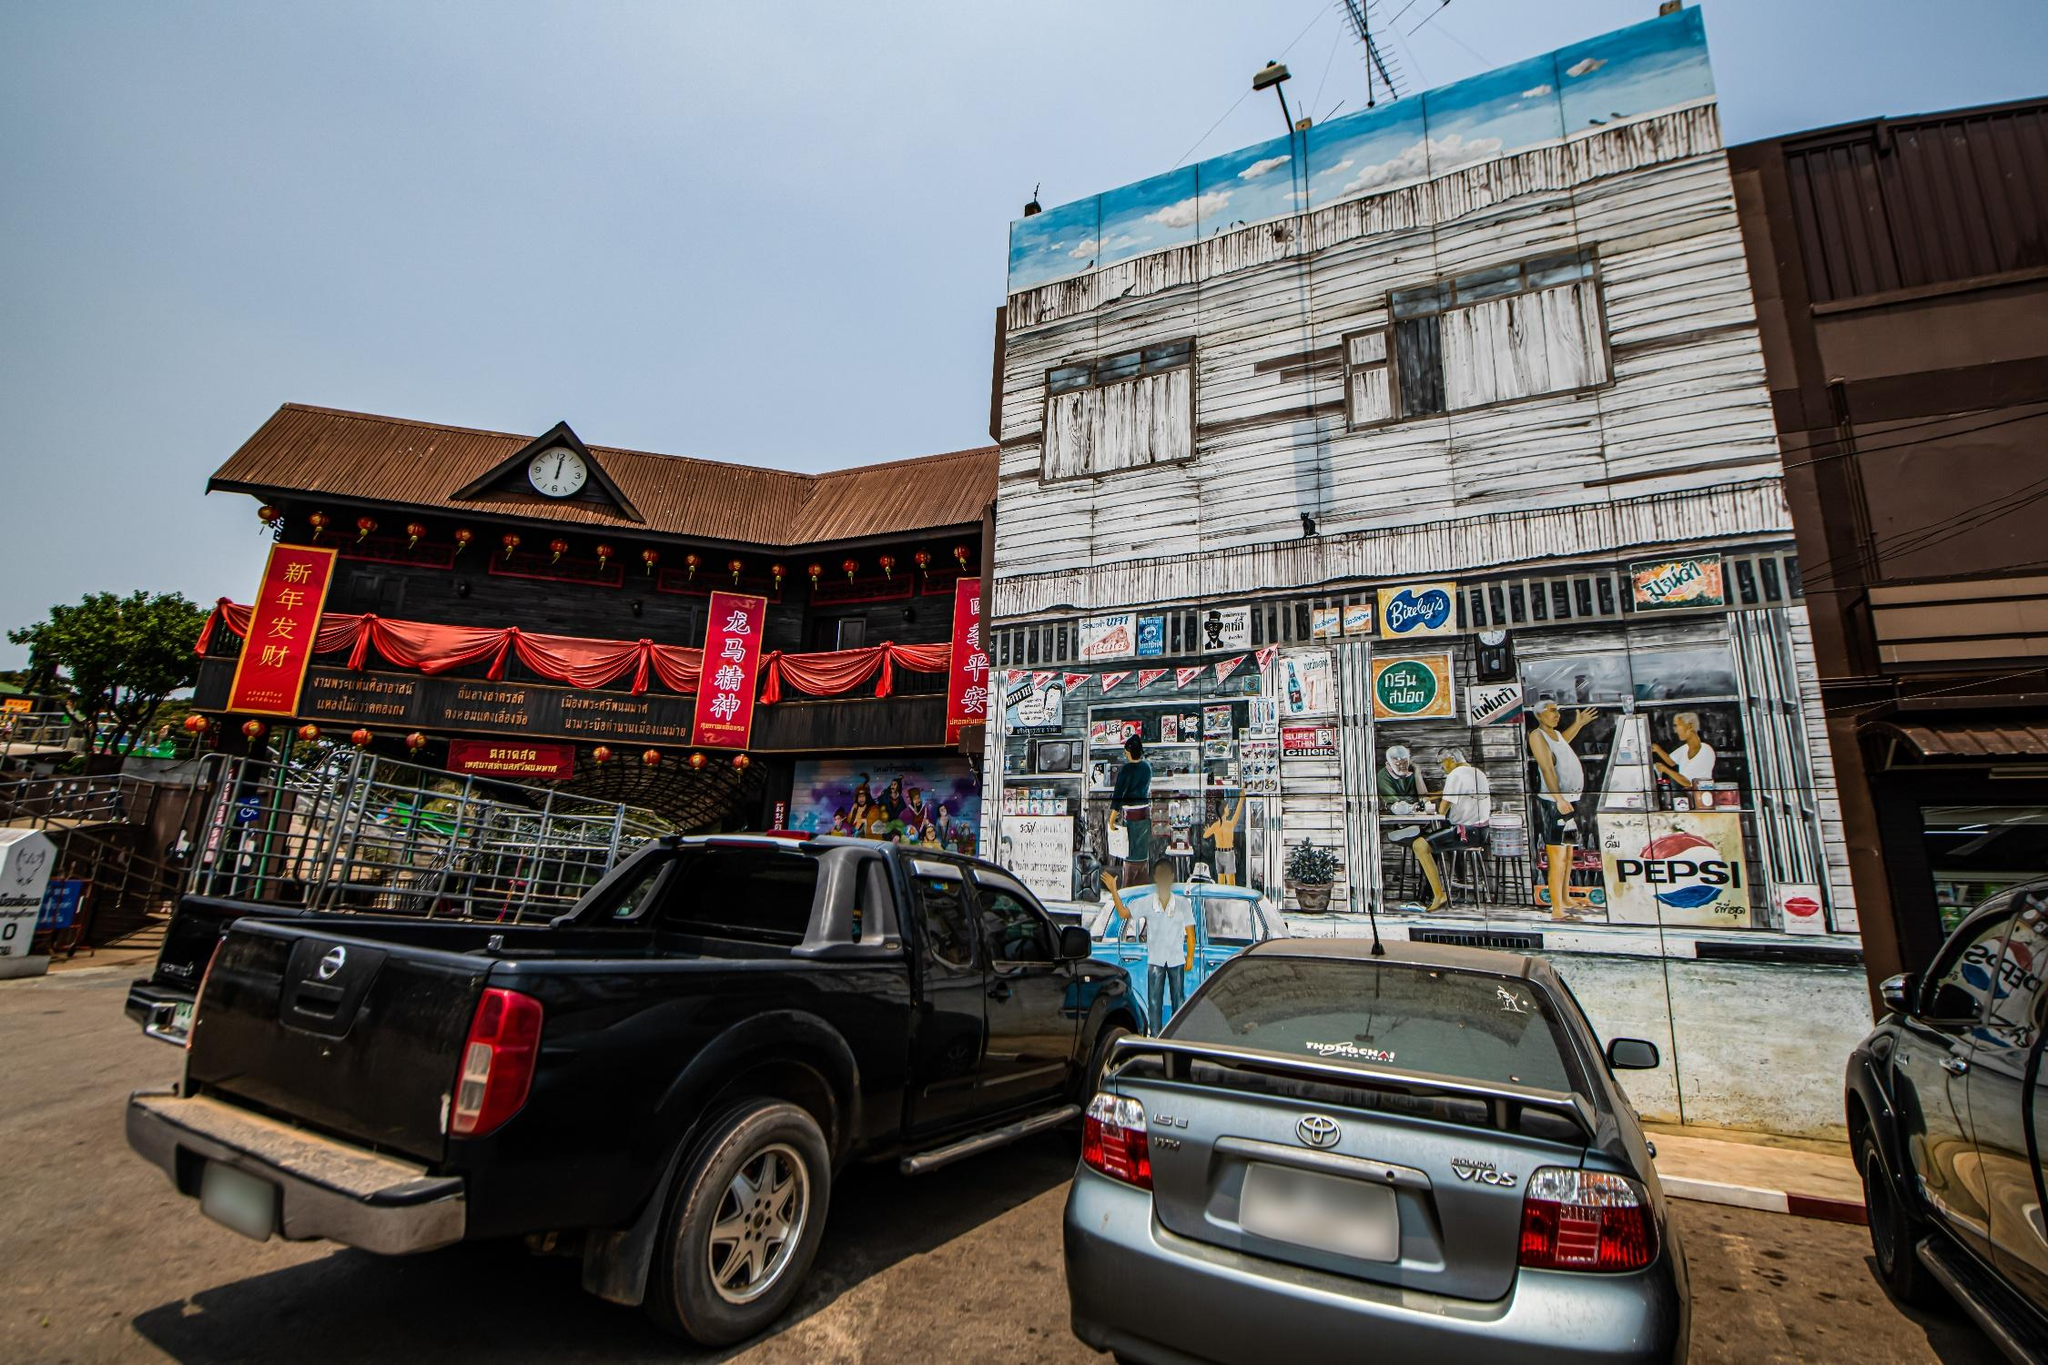Could you describe the role of the vehicles in this street scene? The vehicles in the scene, a black pickup truck and a silver Toyota sedan, are emblematic of personal transportation within the community. Their presence suggests a reliance on motor vehicles for mobility and hints at the socioeconomic status of the residents. Parked along the bustling street, these vehicles likely belong to locals visiting the shops, participating in festival activities, or managing their businesses. They highlight the everyday life and hustle in this Thai urban setting. 